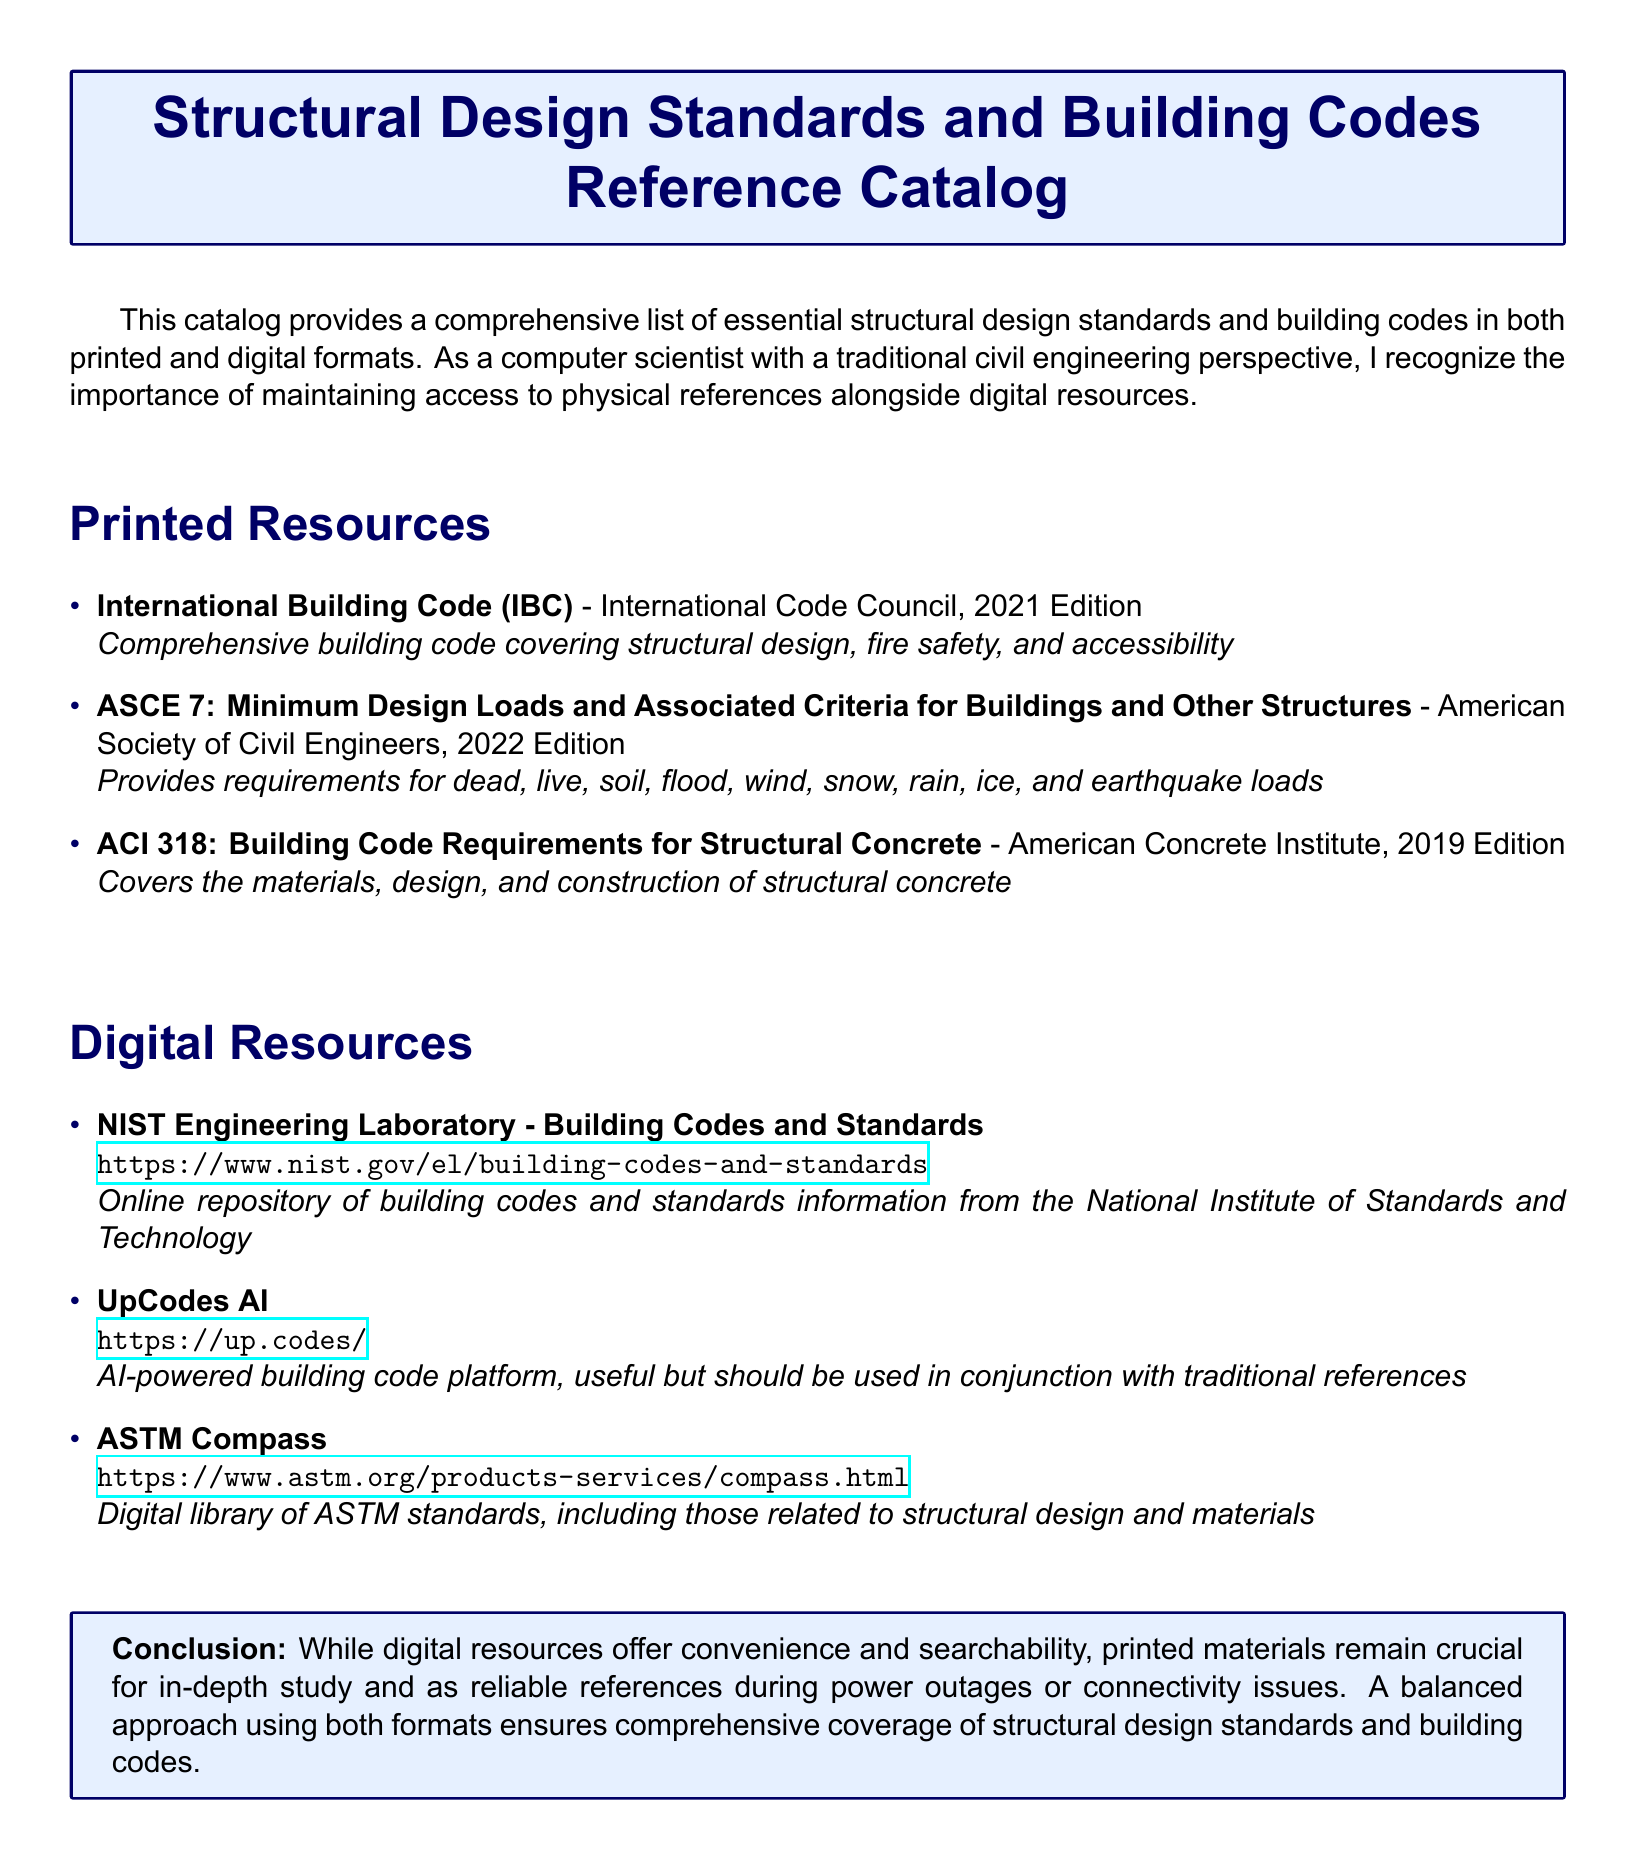What is the title of the catalog? The title is prominently displayed at the beginning of the document, indicating the catalog's focus.
Answer: Structural Design Standards and Building Codes Reference Catalog Who published the International Building Code? The document specifies the publisher of each printed resource, including the International Building Code.
Answer: International Code Council What is the publication year of ASCE 7? Each printed standard includes its publication year; this particular one is specified.
Answer: 2022 Edition What website hosts the NIST Engineering Laboratory? The document provides URLs for digital resources, detailing where each can be accessed.
Answer: https://www.nist.gov/el/building-codes-and-standards Which organization produced the ACI 318? The document attributes each printed resource to its corresponding organization, providing clarity and accountability.
Answer: American Concrete Institute Why is it essential to have printed resources alongside digital ones? The conclusion section offers reasoning on why a balance between formats is crucial for effective study and reliability.
Answer: For in-depth study and reliability Which digital resource is described as AI-powered? Each digital resource description clarifies its unique features; this particular one focuses on AI capabilities.
Answer: UpCodes AI What is the main benefit of digital resources mentioned in the document? The benefits of digital resources are highlighted, emphasizing their usefulness traits.
Answer: Convenience and searchability 